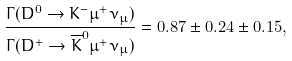Convert formula to latex. <formula><loc_0><loc_0><loc_500><loc_500>\frac { \Gamma ( D ^ { 0 } \rightarrow K ^ { - } \mu ^ { + } \nu _ { \mu } ) } { \Gamma ( D ^ { + } \rightarrow { \overline { K } } ^ { 0 } \mu ^ { + } \nu _ { \mu } ) } = 0 . 8 7 \pm 0 . 2 4 \pm 0 . 1 5 ,</formula> 